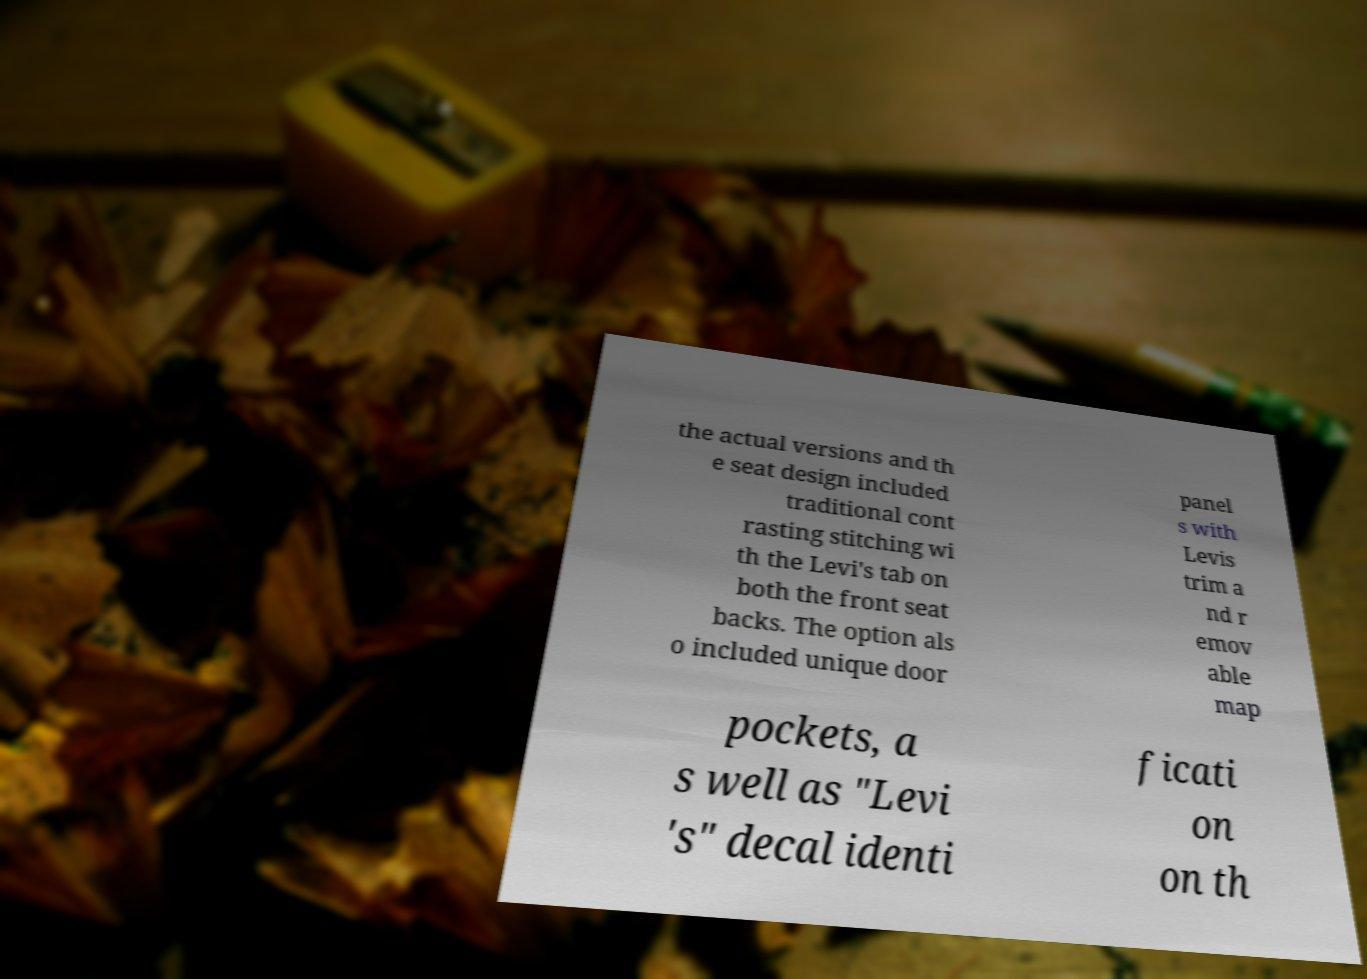Could you assist in decoding the text presented in this image and type it out clearly? the actual versions and th e seat design included traditional cont rasting stitching wi th the Levi's tab on both the front seat backs. The option als o included unique door panel s with Levis trim a nd r emov able map pockets, a s well as "Levi 's" decal identi ficati on on th 